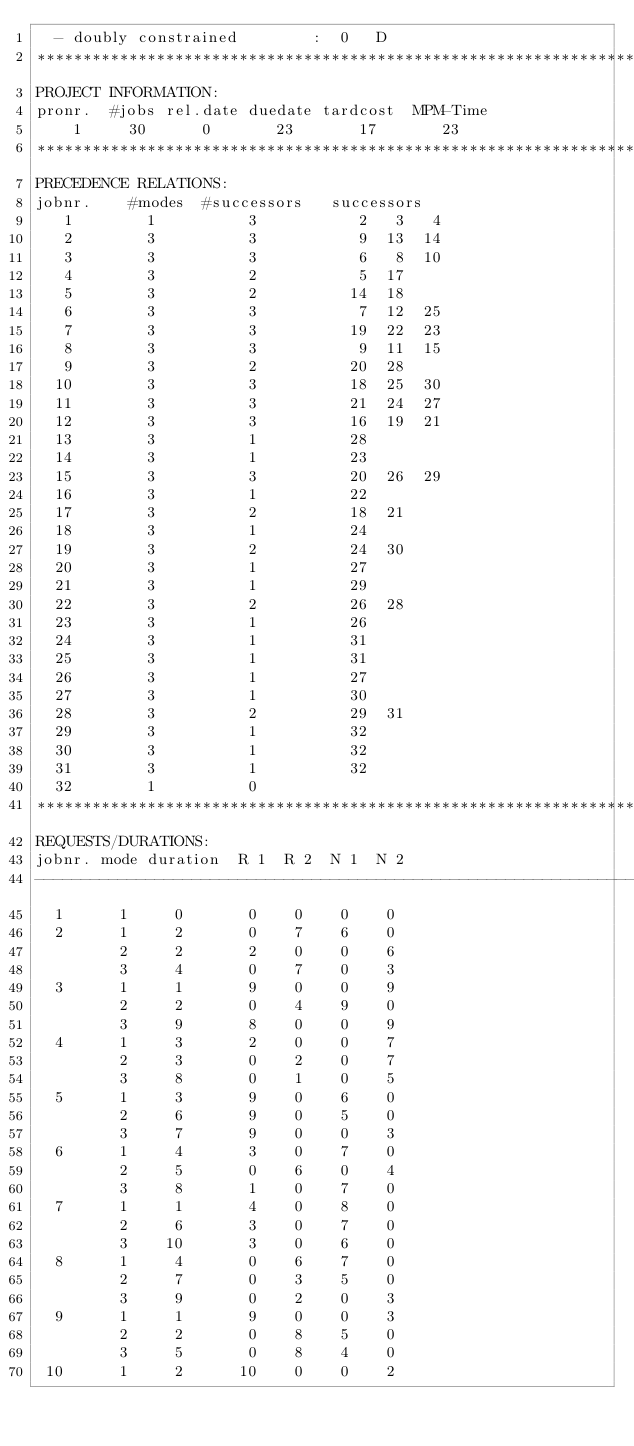<code> <loc_0><loc_0><loc_500><loc_500><_ObjectiveC_>  - doubly constrained        :  0   D
************************************************************************
PROJECT INFORMATION:
pronr.  #jobs rel.date duedate tardcost  MPM-Time
    1     30      0       23       17       23
************************************************************************
PRECEDENCE RELATIONS:
jobnr.    #modes  #successors   successors
   1        1          3           2   3   4
   2        3          3           9  13  14
   3        3          3           6   8  10
   4        3          2           5  17
   5        3          2          14  18
   6        3          3           7  12  25
   7        3          3          19  22  23
   8        3          3           9  11  15
   9        3          2          20  28
  10        3          3          18  25  30
  11        3          3          21  24  27
  12        3          3          16  19  21
  13        3          1          28
  14        3          1          23
  15        3          3          20  26  29
  16        3          1          22
  17        3          2          18  21
  18        3          1          24
  19        3          2          24  30
  20        3          1          27
  21        3          1          29
  22        3          2          26  28
  23        3          1          26
  24        3          1          31
  25        3          1          31
  26        3          1          27
  27        3          1          30
  28        3          2          29  31
  29        3          1          32
  30        3          1          32
  31        3          1          32
  32        1          0        
************************************************************************
REQUESTS/DURATIONS:
jobnr. mode duration  R 1  R 2  N 1  N 2
------------------------------------------------------------------------
  1      1     0       0    0    0    0
  2      1     2       0    7    6    0
         2     2       2    0    0    6
         3     4       0    7    0    3
  3      1     1       9    0    0    9
         2     2       0    4    9    0
         3     9       8    0    0    9
  4      1     3       2    0    0    7
         2     3       0    2    0    7
         3     8       0    1    0    5
  5      1     3       9    0    6    0
         2     6       9    0    5    0
         3     7       9    0    0    3
  6      1     4       3    0    7    0
         2     5       0    6    0    4
         3     8       1    0    7    0
  7      1     1       4    0    8    0
         2     6       3    0    7    0
         3    10       3    0    6    0
  8      1     4       0    6    7    0
         2     7       0    3    5    0
         3     9       0    2    0    3
  9      1     1       9    0    0    3
         2     2       0    8    5    0
         3     5       0    8    4    0
 10      1     2      10    0    0    2</code> 